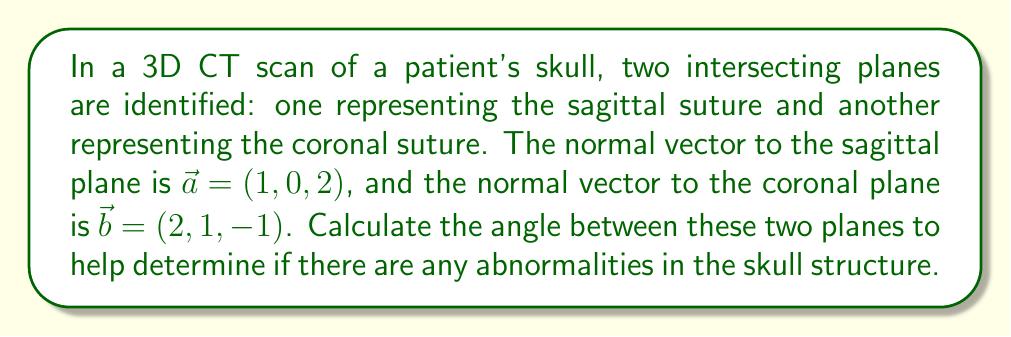Teach me how to tackle this problem. To find the angle between two intersecting planes, we can use the angle between their normal vectors. The formula for the angle $\theta$ between two vectors $\vec{a}$ and $\vec{b}$ is:

$$\cos \theta = \frac{\vec{a} \cdot \vec{b}}{|\vec{a}| |\vec{b}|}$$

Let's solve this step by step:

1) First, calculate the dot product $\vec{a} \cdot \vec{b}$:
   $$\vec{a} \cdot \vec{b} = (1)(2) + (0)(1) + (2)(-1) = 2 + 0 - 2 = 0$$

2) Calculate the magnitudes of $\vec{a}$ and $\vec{b}$:
   $$|\vec{a}| = \sqrt{1^2 + 0^2 + 2^2} = \sqrt{5}$$
   $$|\vec{b}| = \sqrt{2^2 + 1^2 + (-1)^2} = \sqrt{6}$$

3) Substitute these values into the formula:
   $$\cos \theta = \frac{0}{\sqrt{5} \sqrt{6}} = 0$$

4) To find $\theta$, take the inverse cosine (arccos) of both sides:
   $$\theta = \arccos(0) = \frac{\pi}{2} \text{ radians} = 90°$$

Therefore, the angle between the two planes is 90°, or a right angle.
Answer: 90° 